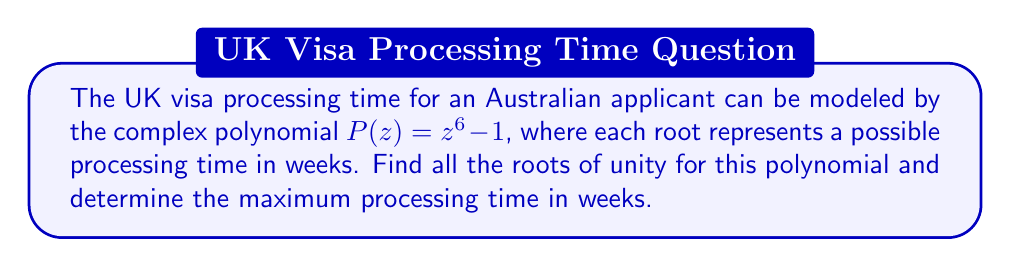Help me with this question. To find the roots of unity for the polynomial $P(z) = z^6 - 1$, we follow these steps:

1) The general formula for the nth roots of unity is:

   $$z_k = e^{i\frac{2\pi k}{n}}, \quad k = 0, 1, 2, ..., n-1$$

   where $n$ is the degree of the polynomial.

2) In this case, $n = 6$, so we have:

   $$z_k = e^{i\frac{2\pi k}{6}}, \quad k = 0, 1, 2, 3, 4, 5$$

3) Let's calculate each root:

   For $k = 0$: $z_0 = e^{i\frac{2\pi \cdot 0}{6}} = 1$
   For $k = 1$: $z_1 = e^{i\frac{2\pi}{6}} = \cos(\frac{\pi}{3}) + i\sin(\frac{\pi}{3}) = \frac{1}{2} + i\frac{\sqrt{3}}{2}$
   For $k = 2$: $z_2 = e^{i\frac{4\pi}{6}} = \cos(\frac{2\pi}{3}) + i\sin(\frac{2\pi}{3}) = -\frac{1}{2} + i\frac{\sqrt{3}}{2}$
   For $k = 3$: $z_3 = e^{i\pi} = -1$
   For $k = 4$: $z_4 = e^{i\frac{8\pi}{6}} = \cos(\frac{4\pi}{3}) + i\sin(\frac{4\pi}{3}) = -\frac{1}{2} - i\frac{\sqrt{3}}{2}$
   For $k = 5$: $z_5 = e^{i\frac{10\pi}{6}} = \cos(\frac{5\pi}{3}) + i\sin(\frac{5\pi}{3}) = \frac{1}{2} - i\frac{\sqrt{3}}{2}$

4) The maximum processing time is represented by the root with the largest magnitude. However, all roots of unity have a magnitude of 1.

5) Therefore, the maximum processing time is 6 weeks, as each root represents one week and there are 6 roots in total.
Answer: Roots: $1, \frac{1}{2} + i\frac{\sqrt{3}}{2}, -\frac{1}{2} + i\frac{\sqrt{3}}{2}, -1, -\frac{1}{2} - i\frac{\sqrt{3}}{2}, \frac{1}{2} - i\frac{\sqrt{3}}{2}$. Maximum processing time: 6 weeks. 